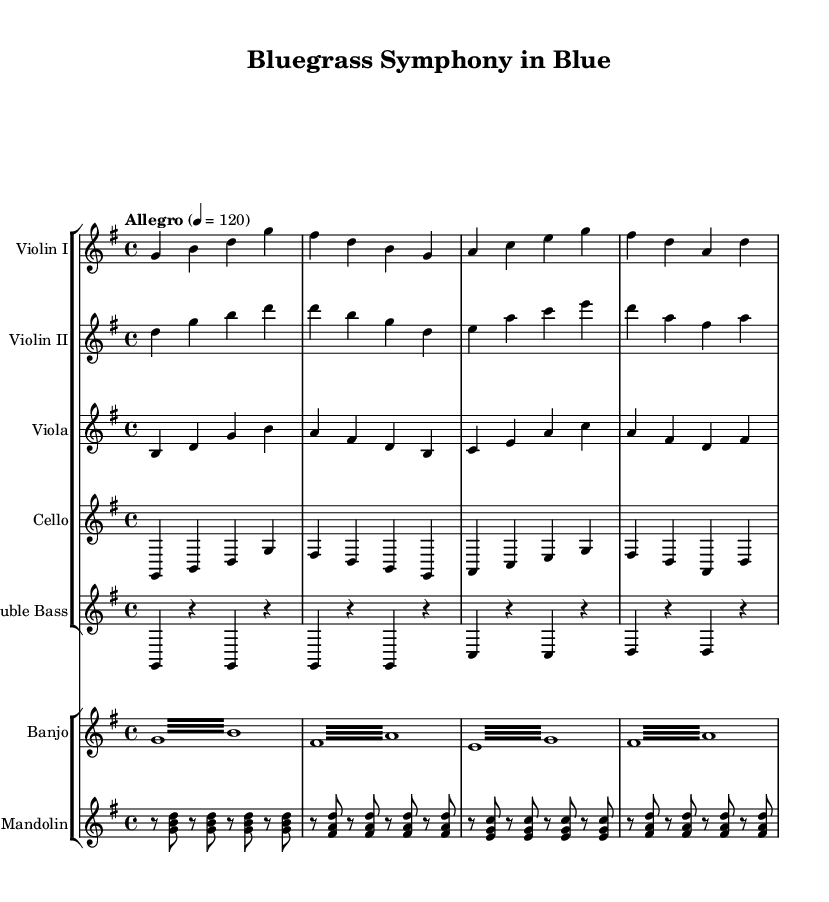What is the key signature of this music? The key signature is G major, which has one sharp (F#). This can be determined by looking at the key signature indicator at the beginning of the score.
Answer: G major What is the time signature of this piece? The time signature is 4/4, indicated right after the key signature. This means there are four beats per measure, and the quarter note gets one beat.
Answer: 4/4 What is the tempo marking of this symphony? The tempo marking is "Allegro," which indicates a fast and lively pace. The quarter note is set to 120 beats per minute, as shown next to the tempo indication.
Answer: Allegro How many instruments are in the first staff group? There are five instruments in the first staff group: Violin I, Violin II, Viola, Cello, and Double Bass. This can be confirmed by counting the labeled staves in that section of the music.
Answer: Five What makes the banjo part unique compared to the violin parts? The banjo part features repeated tremolo notes, which create a rapid, fluttering sound. This is distinct from the violin parts, which contain more sustained notes and less rhythmic variation.
Answer: Tremolo Which instruments play harmonically complementary roles in this symphony? The harmonically complementary roles are primarily played by the Violin I and Violin II parts, with Violin I typically playing the melody while Violin II supports with harmonies. This relationship can be inferred by analyzing their note patterns and how they interact in the score.
Answer: Violin I and Violin II 